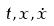<formula> <loc_0><loc_0><loc_500><loc_500>t , x , \dot { x }</formula> 